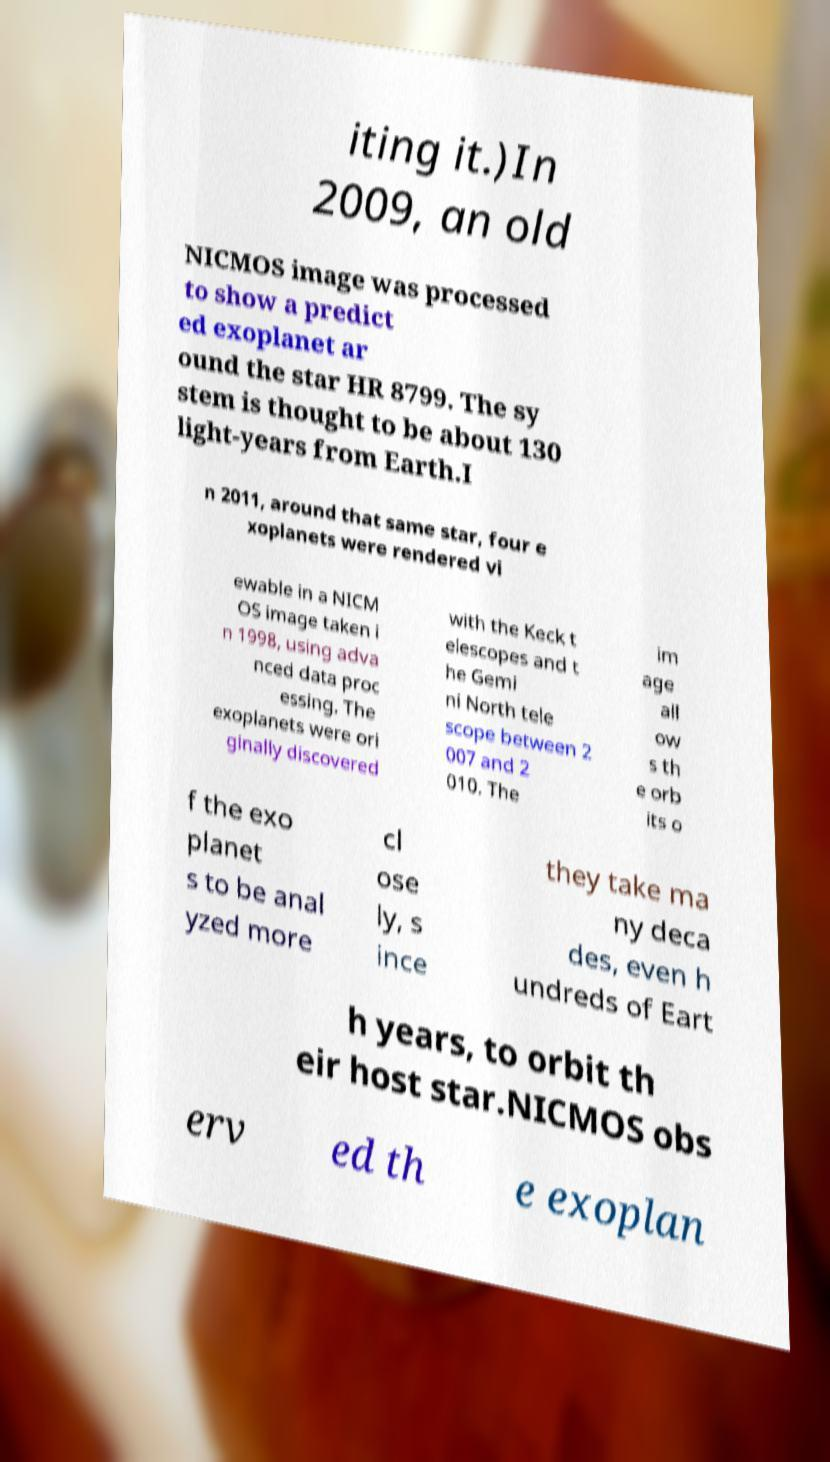There's text embedded in this image that I need extracted. Can you transcribe it verbatim? iting it.)In 2009, an old NICMOS image was processed to show a predict ed exoplanet ar ound the star HR 8799. The sy stem is thought to be about 130 light-years from Earth.I n 2011, around that same star, four e xoplanets were rendered vi ewable in a NICM OS image taken i n 1998, using adva nced data proc essing. The exoplanets were ori ginally discovered with the Keck t elescopes and t he Gemi ni North tele scope between 2 007 and 2 010. The im age all ow s th e orb its o f the exo planet s to be anal yzed more cl ose ly, s ince they take ma ny deca des, even h undreds of Eart h years, to orbit th eir host star.NICMOS obs erv ed th e exoplan 